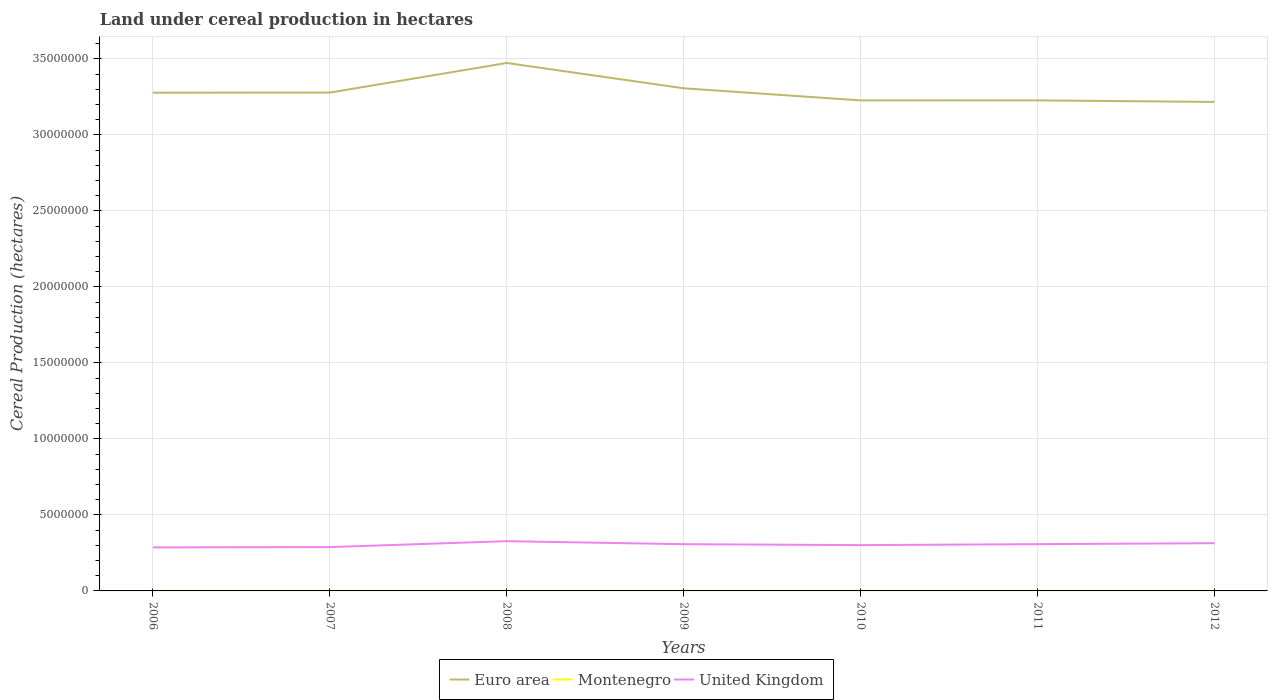How many different coloured lines are there?
Offer a terse response. 3. Across all years, what is the maximum land under cereal production in United Kingdom?
Your answer should be compact. 2.86e+06. In which year was the land under cereal production in United Kingdom maximum?
Make the answer very short. 2006. What is the total land under cereal production in Euro area in the graph?
Give a very brief answer. 7.94e+05. What is the difference between the highest and the second highest land under cereal production in Montenegro?
Your response must be concise. 194. Is the land under cereal production in United Kingdom strictly greater than the land under cereal production in Euro area over the years?
Ensure brevity in your answer.  Yes. Does the graph contain grids?
Your answer should be compact. Yes. Where does the legend appear in the graph?
Make the answer very short. Bottom center. How are the legend labels stacked?
Offer a terse response. Horizontal. What is the title of the graph?
Offer a very short reply. Land under cereal production in hectares. What is the label or title of the Y-axis?
Provide a short and direct response. Cereal Production (hectares). What is the Cereal Production (hectares) in Euro area in 2006?
Offer a very short reply. 3.28e+07. What is the Cereal Production (hectares) of Montenegro in 2006?
Your response must be concise. 4830. What is the Cereal Production (hectares) of United Kingdom in 2006?
Provide a succinct answer. 2.86e+06. What is the Cereal Production (hectares) in Euro area in 2007?
Offer a very short reply. 3.28e+07. What is the Cereal Production (hectares) in Montenegro in 2007?
Provide a short and direct response. 4847. What is the Cereal Production (hectares) in United Kingdom in 2007?
Your response must be concise. 2.88e+06. What is the Cereal Production (hectares) in Euro area in 2008?
Make the answer very short. 3.47e+07. What is the Cereal Production (hectares) of Montenegro in 2008?
Keep it short and to the point. 4746. What is the Cereal Production (hectares) in United Kingdom in 2008?
Keep it short and to the point. 3.27e+06. What is the Cereal Production (hectares) of Euro area in 2009?
Your answer should be compact. 3.31e+07. What is the Cereal Production (hectares) of Montenegro in 2009?
Offer a terse response. 4841. What is the Cereal Production (hectares) in United Kingdom in 2009?
Provide a succinct answer. 3.08e+06. What is the Cereal Production (hectares) in Euro area in 2010?
Offer a terse response. 3.23e+07. What is the Cereal Production (hectares) of Montenegro in 2010?
Offer a very short reply. 4653. What is the Cereal Production (hectares) of United Kingdom in 2010?
Provide a succinct answer. 3.01e+06. What is the Cereal Production (hectares) of Euro area in 2011?
Offer a terse response. 3.23e+07. What is the Cereal Production (hectares) in Montenegro in 2011?
Offer a very short reply. 4795. What is the Cereal Production (hectares) in United Kingdom in 2011?
Your response must be concise. 3.08e+06. What is the Cereal Production (hectares) in Euro area in 2012?
Offer a very short reply. 3.22e+07. What is the Cereal Production (hectares) in Montenegro in 2012?
Ensure brevity in your answer.  4656. What is the Cereal Production (hectares) of United Kingdom in 2012?
Offer a terse response. 3.14e+06. Across all years, what is the maximum Cereal Production (hectares) in Euro area?
Ensure brevity in your answer.  3.47e+07. Across all years, what is the maximum Cereal Production (hectares) of Montenegro?
Keep it short and to the point. 4847. Across all years, what is the maximum Cereal Production (hectares) in United Kingdom?
Keep it short and to the point. 3.27e+06. Across all years, what is the minimum Cereal Production (hectares) of Euro area?
Your response must be concise. 3.22e+07. Across all years, what is the minimum Cereal Production (hectares) in Montenegro?
Your answer should be compact. 4653. Across all years, what is the minimum Cereal Production (hectares) of United Kingdom?
Offer a terse response. 2.86e+06. What is the total Cereal Production (hectares) in Euro area in the graph?
Give a very brief answer. 2.30e+08. What is the total Cereal Production (hectares) in Montenegro in the graph?
Make the answer very short. 3.34e+04. What is the total Cereal Production (hectares) of United Kingdom in the graph?
Your answer should be very brief. 2.13e+07. What is the difference between the Cereal Production (hectares) in Euro area in 2006 and that in 2007?
Your answer should be very brief. -6362. What is the difference between the Cereal Production (hectares) in United Kingdom in 2006 and that in 2007?
Your answer should be compact. -2.04e+04. What is the difference between the Cereal Production (hectares) in Euro area in 2006 and that in 2008?
Offer a terse response. -1.95e+06. What is the difference between the Cereal Production (hectares) of United Kingdom in 2006 and that in 2008?
Offer a terse response. -4.10e+05. What is the difference between the Cereal Production (hectares) of Euro area in 2006 and that in 2009?
Offer a very short reply. -2.89e+05. What is the difference between the Cereal Production (hectares) in Montenegro in 2006 and that in 2009?
Give a very brief answer. -11. What is the difference between the Cereal Production (hectares) in United Kingdom in 2006 and that in 2009?
Make the answer very short. -2.12e+05. What is the difference between the Cereal Production (hectares) of Euro area in 2006 and that in 2010?
Keep it short and to the point. 5.07e+05. What is the difference between the Cereal Production (hectares) of Montenegro in 2006 and that in 2010?
Make the answer very short. 177. What is the difference between the Cereal Production (hectares) in United Kingdom in 2006 and that in 2010?
Your response must be concise. -1.50e+05. What is the difference between the Cereal Production (hectares) in Euro area in 2006 and that in 2011?
Provide a short and direct response. 5.05e+05. What is the difference between the Cereal Production (hectares) of United Kingdom in 2006 and that in 2011?
Keep it short and to the point. -2.13e+05. What is the difference between the Cereal Production (hectares) in Euro area in 2006 and that in 2012?
Your answer should be compact. 6.09e+05. What is the difference between the Cereal Production (hectares) of Montenegro in 2006 and that in 2012?
Make the answer very short. 174. What is the difference between the Cereal Production (hectares) in United Kingdom in 2006 and that in 2012?
Provide a succinct answer. -2.78e+05. What is the difference between the Cereal Production (hectares) in Euro area in 2007 and that in 2008?
Your answer should be compact. -1.95e+06. What is the difference between the Cereal Production (hectares) in Montenegro in 2007 and that in 2008?
Ensure brevity in your answer.  101. What is the difference between the Cereal Production (hectares) of United Kingdom in 2007 and that in 2008?
Provide a short and direct response. -3.89e+05. What is the difference between the Cereal Production (hectares) in Euro area in 2007 and that in 2009?
Provide a succinct answer. -2.82e+05. What is the difference between the Cereal Production (hectares) of Montenegro in 2007 and that in 2009?
Your answer should be very brief. 6. What is the difference between the Cereal Production (hectares) in United Kingdom in 2007 and that in 2009?
Provide a succinct answer. -1.92e+05. What is the difference between the Cereal Production (hectares) of Euro area in 2007 and that in 2010?
Your response must be concise. 5.13e+05. What is the difference between the Cereal Production (hectares) in Montenegro in 2007 and that in 2010?
Ensure brevity in your answer.  194. What is the difference between the Cereal Production (hectares) in United Kingdom in 2007 and that in 2010?
Your answer should be compact. -1.30e+05. What is the difference between the Cereal Production (hectares) of Euro area in 2007 and that in 2011?
Provide a succinct answer. 5.12e+05. What is the difference between the Cereal Production (hectares) in Montenegro in 2007 and that in 2011?
Your answer should be compact. 52. What is the difference between the Cereal Production (hectares) of United Kingdom in 2007 and that in 2011?
Offer a terse response. -1.93e+05. What is the difference between the Cereal Production (hectares) of Euro area in 2007 and that in 2012?
Ensure brevity in your answer.  6.15e+05. What is the difference between the Cereal Production (hectares) in Montenegro in 2007 and that in 2012?
Provide a short and direct response. 191. What is the difference between the Cereal Production (hectares) in United Kingdom in 2007 and that in 2012?
Offer a very short reply. -2.58e+05. What is the difference between the Cereal Production (hectares) of Euro area in 2008 and that in 2009?
Give a very brief answer. 1.67e+06. What is the difference between the Cereal Production (hectares) of Montenegro in 2008 and that in 2009?
Offer a terse response. -95. What is the difference between the Cereal Production (hectares) in United Kingdom in 2008 and that in 2009?
Make the answer very short. 1.97e+05. What is the difference between the Cereal Production (hectares) in Euro area in 2008 and that in 2010?
Your answer should be compact. 2.46e+06. What is the difference between the Cereal Production (hectares) in Montenegro in 2008 and that in 2010?
Ensure brevity in your answer.  93. What is the difference between the Cereal Production (hectares) in United Kingdom in 2008 and that in 2010?
Make the answer very short. 2.60e+05. What is the difference between the Cereal Production (hectares) in Euro area in 2008 and that in 2011?
Offer a terse response. 2.46e+06. What is the difference between the Cereal Production (hectares) of Montenegro in 2008 and that in 2011?
Offer a terse response. -49. What is the difference between the Cereal Production (hectares) of United Kingdom in 2008 and that in 2011?
Offer a terse response. 1.96e+05. What is the difference between the Cereal Production (hectares) of Euro area in 2008 and that in 2012?
Your response must be concise. 2.56e+06. What is the difference between the Cereal Production (hectares) in Montenegro in 2008 and that in 2012?
Your answer should be compact. 90. What is the difference between the Cereal Production (hectares) of United Kingdom in 2008 and that in 2012?
Your answer should be compact. 1.31e+05. What is the difference between the Cereal Production (hectares) in Euro area in 2009 and that in 2010?
Offer a very short reply. 7.96e+05. What is the difference between the Cereal Production (hectares) of Montenegro in 2009 and that in 2010?
Keep it short and to the point. 188. What is the difference between the Cereal Production (hectares) in United Kingdom in 2009 and that in 2010?
Your answer should be very brief. 6.25e+04. What is the difference between the Cereal Production (hectares) of Euro area in 2009 and that in 2011?
Your response must be concise. 7.94e+05. What is the difference between the Cereal Production (hectares) of United Kingdom in 2009 and that in 2011?
Ensure brevity in your answer.  -1000. What is the difference between the Cereal Production (hectares) in Euro area in 2009 and that in 2012?
Your response must be concise. 8.97e+05. What is the difference between the Cereal Production (hectares) in Montenegro in 2009 and that in 2012?
Provide a succinct answer. 185. What is the difference between the Cereal Production (hectares) in United Kingdom in 2009 and that in 2012?
Your answer should be very brief. -6.60e+04. What is the difference between the Cereal Production (hectares) in Euro area in 2010 and that in 2011?
Provide a short and direct response. -1777.62. What is the difference between the Cereal Production (hectares) of Montenegro in 2010 and that in 2011?
Your answer should be compact. -142. What is the difference between the Cereal Production (hectares) of United Kingdom in 2010 and that in 2011?
Your answer should be very brief. -6.35e+04. What is the difference between the Cereal Production (hectares) in Euro area in 2010 and that in 2012?
Offer a terse response. 1.02e+05. What is the difference between the Cereal Production (hectares) of Montenegro in 2010 and that in 2012?
Your answer should be compact. -3. What is the difference between the Cereal Production (hectares) of United Kingdom in 2010 and that in 2012?
Offer a terse response. -1.28e+05. What is the difference between the Cereal Production (hectares) of Euro area in 2011 and that in 2012?
Ensure brevity in your answer.  1.03e+05. What is the difference between the Cereal Production (hectares) of Montenegro in 2011 and that in 2012?
Provide a short and direct response. 139. What is the difference between the Cereal Production (hectares) in United Kingdom in 2011 and that in 2012?
Your response must be concise. -6.50e+04. What is the difference between the Cereal Production (hectares) in Euro area in 2006 and the Cereal Production (hectares) in Montenegro in 2007?
Offer a terse response. 3.28e+07. What is the difference between the Cereal Production (hectares) in Euro area in 2006 and the Cereal Production (hectares) in United Kingdom in 2007?
Your answer should be very brief. 2.99e+07. What is the difference between the Cereal Production (hectares) of Montenegro in 2006 and the Cereal Production (hectares) of United Kingdom in 2007?
Provide a succinct answer. -2.88e+06. What is the difference between the Cereal Production (hectares) of Euro area in 2006 and the Cereal Production (hectares) of Montenegro in 2008?
Make the answer very short. 3.28e+07. What is the difference between the Cereal Production (hectares) in Euro area in 2006 and the Cereal Production (hectares) in United Kingdom in 2008?
Your answer should be compact. 2.95e+07. What is the difference between the Cereal Production (hectares) of Montenegro in 2006 and the Cereal Production (hectares) of United Kingdom in 2008?
Make the answer very short. -3.27e+06. What is the difference between the Cereal Production (hectares) in Euro area in 2006 and the Cereal Production (hectares) in Montenegro in 2009?
Offer a terse response. 3.28e+07. What is the difference between the Cereal Production (hectares) of Euro area in 2006 and the Cereal Production (hectares) of United Kingdom in 2009?
Make the answer very short. 2.97e+07. What is the difference between the Cereal Production (hectares) in Montenegro in 2006 and the Cereal Production (hectares) in United Kingdom in 2009?
Ensure brevity in your answer.  -3.07e+06. What is the difference between the Cereal Production (hectares) of Euro area in 2006 and the Cereal Production (hectares) of Montenegro in 2010?
Make the answer very short. 3.28e+07. What is the difference between the Cereal Production (hectares) in Euro area in 2006 and the Cereal Production (hectares) in United Kingdom in 2010?
Give a very brief answer. 2.98e+07. What is the difference between the Cereal Production (hectares) of Montenegro in 2006 and the Cereal Production (hectares) of United Kingdom in 2010?
Offer a very short reply. -3.01e+06. What is the difference between the Cereal Production (hectares) of Euro area in 2006 and the Cereal Production (hectares) of Montenegro in 2011?
Your answer should be compact. 3.28e+07. What is the difference between the Cereal Production (hectares) of Euro area in 2006 and the Cereal Production (hectares) of United Kingdom in 2011?
Give a very brief answer. 2.97e+07. What is the difference between the Cereal Production (hectares) of Montenegro in 2006 and the Cereal Production (hectares) of United Kingdom in 2011?
Give a very brief answer. -3.07e+06. What is the difference between the Cereal Production (hectares) in Euro area in 2006 and the Cereal Production (hectares) in Montenegro in 2012?
Offer a terse response. 3.28e+07. What is the difference between the Cereal Production (hectares) of Euro area in 2006 and the Cereal Production (hectares) of United Kingdom in 2012?
Make the answer very short. 2.96e+07. What is the difference between the Cereal Production (hectares) of Montenegro in 2006 and the Cereal Production (hectares) of United Kingdom in 2012?
Your response must be concise. -3.14e+06. What is the difference between the Cereal Production (hectares) in Euro area in 2007 and the Cereal Production (hectares) in Montenegro in 2008?
Ensure brevity in your answer.  3.28e+07. What is the difference between the Cereal Production (hectares) in Euro area in 2007 and the Cereal Production (hectares) in United Kingdom in 2008?
Make the answer very short. 2.95e+07. What is the difference between the Cereal Production (hectares) of Montenegro in 2007 and the Cereal Production (hectares) of United Kingdom in 2008?
Ensure brevity in your answer.  -3.27e+06. What is the difference between the Cereal Production (hectares) of Euro area in 2007 and the Cereal Production (hectares) of Montenegro in 2009?
Offer a very short reply. 3.28e+07. What is the difference between the Cereal Production (hectares) in Euro area in 2007 and the Cereal Production (hectares) in United Kingdom in 2009?
Your answer should be very brief. 2.97e+07. What is the difference between the Cereal Production (hectares) of Montenegro in 2007 and the Cereal Production (hectares) of United Kingdom in 2009?
Your response must be concise. -3.07e+06. What is the difference between the Cereal Production (hectares) of Euro area in 2007 and the Cereal Production (hectares) of Montenegro in 2010?
Your answer should be very brief. 3.28e+07. What is the difference between the Cereal Production (hectares) in Euro area in 2007 and the Cereal Production (hectares) in United Kingdom in 2010?
Offer a terse response. 2.98e+07. What is the difference between the Cereal Production (hectares) in Montenegro in 2007 and the Cereal Production (hectares) in United Kingdom in 2010?
Give a very brief answer. -3.01e+06. What is the difference between the Cereal Production (hectares) in Euro area in 2007 and the Cereal Production (hectares) in Montenegro in 2011?
Make the answer very short. 3.28e+07. What is the difference between the Cereal Production (hectares) of Euro area in 2007 and the Cereal Production (hectares) of United Kingdom in 2011?
Offer a very short reply. 2.97e+07. What is the difference between the Cereal Production (hectares) of Montenegro in 2007 and the Cereal Production (hectares) of United Kingdom in 2011?
Give a very brief answer. -3.07e+06. What is the difference between the Cereal Production (hectares) of Euro area in 2007 and the Cereal Production (hectares) of Montenegro in 2012?
Your answer should be compact. 3.28e+07. What is the difference between the Cereal Production (hectares) of Euro area in 2007 and the Cereal Production (hectares) of United Kingdom in 2012?
Ensure brevity in your answer.  2.96e+07. What is the difference between the Cereal Production (hectares) in Montenegro in 2007 and the Cereal Production (hectares) in United Kingdom in 2012?
Your response must be concise. -3.14e+06. What is the difference between the Cereal Production (hectares) of Euro area in 2008 and the Cereal Production (hectares) of Montenegro in 2009?
Provide a succinct answer. 3.47e+07. What is the difference between the Cereal Production (hectares) of Euro area in 2008 and the Cereal Production (hectares) of United Kingdom in 2009?
Make the answer very short. 3.17e+07. What is the difference between the Cereal Production (hectares) of Montenegro in 2008 and the Cereal Production (hectares) of United Kingdom in 2009?
Provide a short and direct response. -3.07e+06. What is the difference between the Cereal Production (hectares) in Euro area in 2008 and the Cereal Production (hectares) in Montenegro in 2010?
Ensure brevity in your answer.  3.47e+07. What is the difference between the Cereal Production (hectares) in Euro area in 2008 and the Cereal Production (hectares) in United Kingdom in 2010?
Provide a succinct answer. 3.17e+07. What is the difference between the Cereal Production (hectares) in Montenegro in 2008 and the Cereal Production (hectares) in United Kingdom in 2010?
Ensure brevity in your answer.  -3.01e+06. What is the difference between the Cereal Production (hectares) in Euro area in 2008 and the Cereal Production (hectares) in Montenegro in 2011?
Provide a succinct answer. 3.47e+07. What is the difference between the Cereal Production (hectares) in Euro area in 2008 and the Cereal Production (hectares) in United Kingdom in 2011?
Give a very brief answer. 3.17e+07. What is the difference between the Cereal Production (hectares) of Montenegro in 2008 and the Cereal Production (hectares) of United Kingdom in 2011?
Your answer should be very brief. -3.07e+06. What is the difference between the Cereal Production (hectares) in Euro area in 2008 and the Cereal Production (hectares) in Montenegro in 2012?
Provide a short and direct response. 3.47e+07. What is the difference between the Cereal Production (hectares) in Euro area in 2008 and the Cereal Production (hectares) in United Kingdom in 2012?
Make the answer very short. 3.16e+07. What is the difference between the Cereal Production (hectares) in Montenegro in 2008 and the Cereal Production (hectares) in United Kingdom in 2012?
Make the answer very short. -3.14e+06. What is the difference between the Cereal Production (hectares) in Euro area in 2009 and the Cereal Production (hectares) in Montenegro in 2010?
Keep it short and to the point. 3.31e+07. What is the difference between the Cereal Production (hectares) in Euro area in 2009 and the Cereal Production (hectares) in United Kingdom in 2010?
Offer a very short reply. 3.01e+07. What is the difference between the Cereal Production (hectares) in Montenegro in 2009 and the Cereal Production (hectares) in United Kingdom in 2010?
Keep it short and to the point. -3.01e+06. What is the difference between the Cereal Production (hectares) of Euro area in 2009 and the Cereal Production (hectares) of Montenegro in 2011?
Provide a short and direct response. 3.31e+07. What is the difference between the Cereal Production (hectares) in Euro area in 2009 and the Cereal Production (hectares) in United Kingdom in 2011?
Offer a very short reply. 3.00e+07. What is the difference between the Cereal Production (hectares) in Montenegro in 2009 and the Cereal Production (hectares) in United Kingdom in 2011?
Make the answer very short. -3.07e+06. What is the difference between the Cereal Production (hectares) in Euro area in 2009 and the Cereal Production (hectares) in Montenegro in 2012?
Your response must be concise. 3.31e+07. What is the difference between the Cereal Production (hectares) of Euro area in 2009 and the Cereal Production (hectares) of United Kingdom in 2012?
Your answer should be compact. 2.99e+07. What is the difference between the Cereal Production (hectares) of Montenegro in 2009 and the Cereal Production (hectares) of United Kingdom in 2012?
Keep it short and to the point. -3.14e+06. What is the difference between the Cereal Production (hectares) of Euro area in 2010 and the Cereal Production (hectares) of Montenegro in 2011?
Your answer should be very brief. 3.23e+07. What is the difference between the Cereal Production (hectares) of Euro area in 2010 and the Cereal Production (hectares) of United Kingdom in 2011?
Provide a short and direct response. 2.92e+07. What is the difference between the Cereal Production (hectares) in Montenegro in 2010 and the Cereal Production (hectares) in United Kingdom in 2011?
Your answer should be very brief. -3.07e+06. What is the difference between the Cereal Production (hectares) of Euro area in 2010 and the Cereal Production (hectares) of Montenegro in 2012?
Offer a very short reply. 3.23e+07. What is the difference between the Cereal Production (hectares) in Euro area in 2010 and the Cereal Production (hectares) in United Kingdom in 2012?
Your response must be concise. 2.91e+07. What is the difference between the Cereal Production (hectares) of Montenegro in 2010 and the Cereal Production (hectares) of United Kingdom in 2012?
Offer a terse response. -3.14e+06. What is the difference between the Cereal Production (hectares) of Euro area in 2011 and the Cereal Production (hectares) of Montenegro in 2012?
Ensure brevity in your answer.  3.23e+07. What is the difference between the Cereal Production (hectares) of Euro area in 2011 and the Cereal Production (hectares) of United Kingdom in 2012?
Your response must be concise. 2.91e+07. What is the difference between the Cereal Production (hectares) of Montenegro in 2011 and the Cereal Production (hectares) of United Kingdom in 2012?
Provide a succinct answer. -3.14e+06. What is the average Cereal Production (hectares) in Euro area per year?
Give a very brief answer. 3.29e+07. What is the average Cereal Production (hectares) in Montenegro per year?
Make the answer very short. 4766.86. What is the average Cereal Production (hectares) in United Kingdom per year?
Keep it short and to the point. 3.05e+06. In the year 2006, what is the difference between the Cereal Production (hectares) in Euro area and Cereal Production (hectares) in Montenegro?
Ensure brevity in your answer.  3.28e+07. In the year 2006, what is the difference between the Cereal Production (hectares) of Euro area and Cereal Production (hectares) of United Kingdom?
Keep it short and to the point. 2.99e+07. In the year 2006, what is the difference between the Cereal Production (hectares) in Montenegro and Cereal Production (hectares) in United Kingdom?
Ensure brevity in your answer.  -2.86e+06. In the year 2007, what is the difference between the Cereal Production (hectares) of Euro area and Cereal Production (hectares) of Montenegro?
Ensure brevity in your answer.  3.28e+07. In the year 2007, what is the difference between the Cereal Production (hectares) of Euro area and Cereal Production (hectares) of United Kingdom?
Offer a very short reply. 2.99e+07. In the year 2007, what is the difference between the Cereal Production (hectares) in Montenegro and Cereal Production (hectares) in United Kingdom?
Ensure brevity in your answer.  -2.88e+06. In the year 2008, what is the difference between the Cereal Production (hectares) in Euro area and Cereal Production (hectares) in Montenegro?
Make the answer very short. 3.47e+07. In the year 2008, what is the difference between the Cereal Production (hectares) in Euro area and Cereal Production (hectares) in United Kingdom?
Provide a succinct answer. 3.15e+07. In the year 2008, what is the difference between the Cereal Production (hectares) in Montenegro and Cereal Production (hectares) in United Kingdom?
Your response must be concise. -3.27e+06. In the year 2009, what is the difference between the Cereal Production (hectares) in Euro area and Cereal Production (hectares) in Montenegro?
Give a very brief answer. 3.31e+07. In the year 2009, what is the difference between the Cereal Production (hectares) in Euro area and Cereal Production (hectares) in United Kingdom?
Provide a short and direct response. 3.00e+07. In the year 2009, what is the difference between the Cereal Production (hectares) in Montenegro and Cereal Production (hectares) in United Kingdom?
Provide a short and direct response. -3.07e+06. In the year 2010, what is the difference between the Cereal Production (hectares) in Euro area and Cereal Production (hectares) in Montenegro?
Offer a very short reply. 3.23e+07. In the year 2010, what is the difference between the Cereal Production (hectares) in Euro area and Cereal Production (hectares) in United Kingdom?
Offer a terse response. 2.93e+07. In the year 2010, what is the difference between the Cereal Production (hectares) in Montenegro and Cereal Production (hectares) in United Kingdom?
Provide a short and direct response. -3.01e+06. In the year 2011, what is the difference between the Cereal Production (hectares) of Euro area and Cereal Production (hectares) of Montenegro?
Offer a terse response. 3.23e+07. In the year 2011, what is the difference between the Cereal Production (hectares) of Euro area and Cereal Production (hectares) of United Kingdom?
Provide a succinct answer. 2.92e+07. In the year 2011, what is the difference between the Cereal Production (hectares) of Montenegro and Cereal Production (hectares) of United Kingdom?
Ensure brevity in your answer.  -3.07e+06. In the year 2012, what is the difference between the Cereal Production (hectares) of Euro area and Cereal Production (hectares) of Montenegro?
Your response must be concise. 3.22e+07. In the year 2012, what is the difference between the Cereal Production (hectares) of Euro area and Cereal Production (hectares) of United Kingdom?
Keep it short and to the point. 2.90e+07. In the year 2012, what is the difference between the Cereal Production (hectares) of Montenegro and Cereal Production (hectares) of United Kingdom?
Keep it short and to the point. -3.14e+06. What is the ratio of the Cereal Production (hectares) of United Kingdom in 2006 to that in 2007?
Offer a terse response. 0.99. What is the ratio of the Cereal Production (hectares) in Euro area in 2006 to that in 2008?
Give a very brief answer. 0.94. What is the ratio of the Cereal Production (hectares) in Montenegro in 2006 to that in 2008?
Your answer should be very brief. 1.02. What is the ratio of the Cereal Production (hectares) in United Kingdom in 2006 to that in 2008?
Your answer should be compact. 0.87. What is the ratio of the Cereal Production (hectares) in Euro area in 2006 to that in 2009?
Provide a succinct answer. 0.99. What is the ratio of the Cereal Production (hectares) of Montenegro in 2006 to that in 2009?
Provide a succinct answer. 1. What is the ratio of the Cereal Production (hectares) in United Kingdom in 2006 to that in 2009?
Provide a succinct answer. 0.93. What is the ratio of the Cereal Production (hectares) of Euro area in 2006 to that in 2010?
Your answer should be very brief. 1.02. What is the ratio of the Cereal Production (hectares) in Montenegro in 2006 to that in 2010?
Your response must be concise. 1.04. What is the ratio of the Cereal Production (hectares) of United Kingdom in 2006 to that in 2010?
Make the answer very short. 0.95. What is the ratio of the Cereal Production (hectares) of Euro area in 2006 to that in 2011?
Your response must be concise. 1.02. What is the ratio of the Cereal Production (hectares) of Montenegro in 2006 to that in 2011?
Your response must be concise. 1.01. What is the ratio of the Cereal Production (hectares) of United Kingdom in 2006 to that in 2011?
Offer a terse response. 0.93. What is the ratio of the Cereal Production (hectares) in Euro area in 2006 to that in 2012?
Your response must be concise. 1.02. What is the ratio of the Cereal Production (hectares) in Montenegro in 2006 to that in 2012?
Your response must be concise. 1.04. What is the ratio of the Cereal Production (hectares) of United Kingdom in 2006 to that in 2012?
Make the answer very short. 0.91. What is the ratio of the Cereal Production (hectares) in Euro area in 2007 to that in 2008?
Offer a very short reply. 0.94. What is the ratio of the Cereal Production (hectares) in Montenegro in 2007 to that in 2008?
Provide a short and direct response. 1.02. What is the ratio of the Cereal Production (hectares) of United Kingdom in 2007 to that in 2008?
Give a very brief answer. 0.88. What is the ratio of the Cereal Production (hectares) in Euro area in 2007 to that in 2009?
Your answer should be compact. 0.99. What is the ratio of the Cereal Production (hectares) of United Kingdom in 2007 to that in 2009?
Provide a short and direct response. 0.94. What is the ratio of the Cereal Production (hectares) of Euro area in 2007 to that in 2010?
Offer a terse response. 1.02. What is the ratio of the Cereal Production (hectares) of Montenegro in 2007 to that in 2010?
Provide a short and direct response. 1.04. What is the ratio of the Cereal Production (hectares) of United Kingdom in 2007 to that in 2010?
Make the answer very short. 0.96. What is the ratio of the Cereal Production (hectares) of Euro area in 2007 to that in 2011?
Keep it short and to the point. 1.02. What is the ratio of the Cereal Production (hectares) of Montenegro in 2007 to that in 2011?
Your answer should be compact. 1.01. What is the ratio of the Cereal Production (hectares) of United Kingdom in 2007 to that in 2011?
Your answer should be compact. 0.94. What is the ratio of the Cereal Production (hectares) in Euro area in 2007 to that in 2012?
Give a very brief answer. 1.02. What is the ratio of the Cereal Production (hectares) of Montenegro in 2007 to that in 2012?
Provide a succinct answer. 1.04. What is the ratio of the Cereal Production (hectares) in United Kingdom in 2007 to that in 2012?
Keep it short and to the point. 0.92. What is the ratio of the Cereal Production (hectares) in Euro area in 2008 to that in 2009?
Ensure brevity in your answer.  1.05. What is the ratio of the Cereal Production (hectares) in Montenegro in 2008 to that in 2009?
Make the answer very short. 0.98. What is the ratio of the Cereal Production (hectares) in United Kingdom in 2008 to that in 2009?
Keep it short and to the point. 1.06. What is the ratio of the Cereal Production (hectares) of Euro area in 2008 to that in 2010?
Your response must be concise. 1.08. What is the ratio of the Cereal Production (hectares) in United Kingdom in 2008 to that in 2010?
Provide a short and direct response. 1.09. What is the ratio of the Cereal Production (hectares) in Euro area in 2008 to that in 2011?
Offer a terse response. 1.08. What is the ratio of the Cereal Production (hectares) of United Kingdom in 2008 to that in 2011?
Offer a very short reply. 1.06. What is the ratio of the Cereal Production (hectares) of Euro area in 2008 to that in 2012?
Your answer should be very brief. 1.08. What is the ratio of the Cereal Production (hectares) in Montenegro in 2008 to that in 2012?
Provide a short and direct response. 1.02. What is the ratio of the Cereal Production (hectares) in United Kingdom in 2008 to that in 2012?
Keep it short and to the point. 1.04. What is the ratio of the Cereal Production (hectares) of Euro area in 2009 to that in 2010?
Give a very brief answer. 1.02. What is the ratio of the Cereal Production (hectares) in Montenegro in 2009 to that in 2010?
Your answer should be compact. 1.04. What is the ratio of the Cereal Production (hectares) in United Kingdom in 2009 to that in 2010?
Ensure brevity in your answer.  1.02. What is the ratio of the Cereal Production (hectares) of Euro area in 2009 to that in 2011?
Keep it short and to the point. 1.02. What is the ratio of the Cereal Production (hectares) of Montenegro in 2009 to that in 2011?
Offer a very short reply. 1.01. What is the ratio of the Cereal Production (hectares) in Euro area in 2009 to that in 2012?
Your answer should be compact. 1.03. What is the ratio of the Cereal Production (hectares) in Montenegro in 2009 to that in 2012?
Your answer should be very brief. 1.04. What is the ratio of the Cereal Production (hectares) in United Kingdom in 2009 to that in 2012?
Provide a short and direct response. 0.98. What is the ratio of the Cereal Production (hectares) in Montenegro in 2010 to that in 2011?
Provide a succinct answer. 0.97. What is the ratio of the Cereal Production (hectares) in United Kingdom in 2010 to that in 2011?
Keep it short and to the point. 0.98. What is the ratio of the Cereal Production (hectares) in Montenegro in 2010 to that in 2012?
Ensure brevity in your answer.  1. What is the ratio of the Cereal Production (hectares) of United Kingdom in 2010 to that in 2012?
Your response must be concise. 0.96. What is the ratio of the Cereal Production (hectares) of Montenegro in 2011 to that in 2012?
Your answer should be very brief. 1.03. What is the ratio of the Cereal Production (hectares) of United Kingdom in 2011 to that in 2012?
Make the answer very short. 0.98. What is the difference between the highest and the second highest Cereal Production (hectares) of Euro area?
Provide a succinct answer. 1.67e+06. What is the difference between the highest and the second highest Cereal Production (hectares) in Montenegro?
Provide a succinct answer. 6. What is the difference between the highest and the second highest Cereal Production (hectares) in United Kingdom?
Offer a very short reply. 1.31e+05. What is the difference between the highest and the lowest Cereal Production (hectares) in Euro area?
Keep it short and to the point. 2.56e+06. What is the difference between the highest and the lowest Cereal Production (hectares) of Montenegro?
Your answer should be compact. 194. What is the difference between the highest and the lowest Cereal Production (hectares) in United Kingdom?
Your answer should be compact. 4.10e+05. 